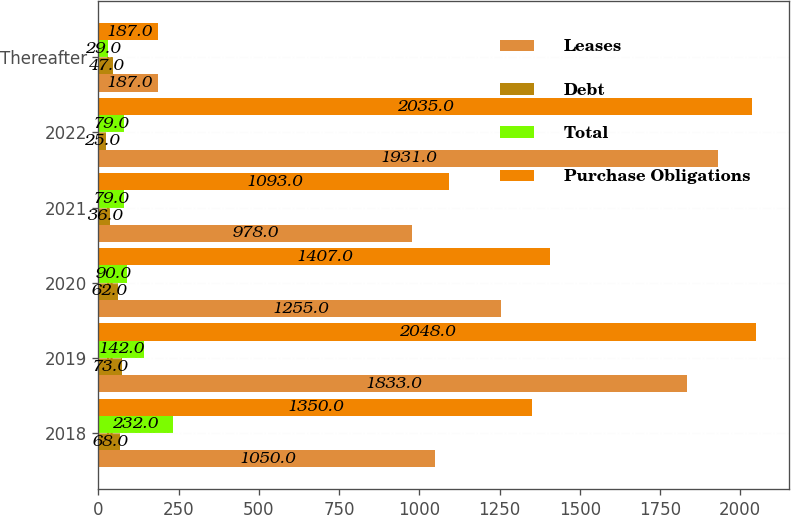<chart> <loc_0><loc_0><loc_500><loc_500><stacked_bar_chart><ecel><fcel>2018<fcel>2019<fcel>2020<fcel>2021<fcel>2022<fcel>Thereafter<nl><fcel>Leases<fcel>1050<fcel>1833<fcel>1255<fcel>978<fcel>1931<fcel>187<nl><fcel>Debt<fcel>68<fcel>73<fcel>62<fcel>36<fcel>25<fcel>47<nl><fcel>Total<fcel>232<fcel>142<fcel>90<fcel>79<fcel>79<fcel>29<nl><fcel>Purchase Obligations<fcel>1350<fcel>2048<fcel>1407<fcel>1093<fcel>2035<fcel>187<nl></chart> 